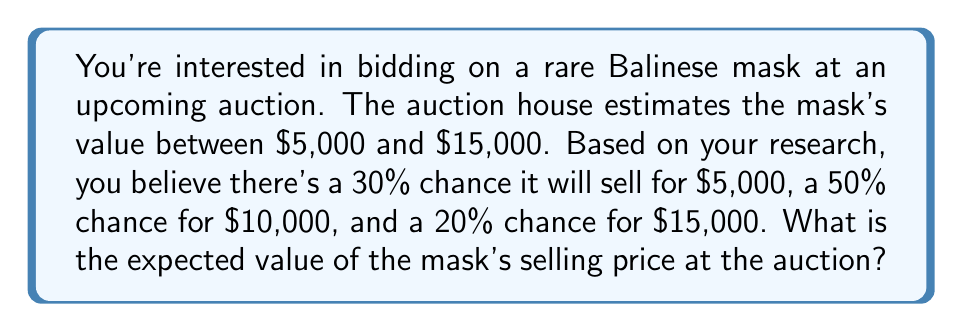What is the answer to this math problem? To calculate the expected value, we need to multiply each possible outcome by its probability and then sum these products. Let's break it down step-by-step:

1. Define the possible outcomes and their probabilities:
   - $5,000 with 30% probability (0.30)
   - $10,000 with 50% probability (0.50)
   - $15,000 with 20% probability (0.20)

2. Calculate the contribution of each outcome to the expected value:
   - For $5,000: $5,000 \times 0.30 = $1,500
   - For $10,000: $10,000 \times 0.50 = $5,000
   - For $15,000: $15,000 \times 0.20 = $3,000

3. Sum up all the contributions:
   $$E = (5000 \times 0.30) + (10000 \times 0.50) + (15000 \times 0.20)$$
   $$E = 1500 + 5000 + 3000 = 9500$$

Therefore, the expected value of the mask's selling price at the auction is $9,500.
Answer: $9,500 